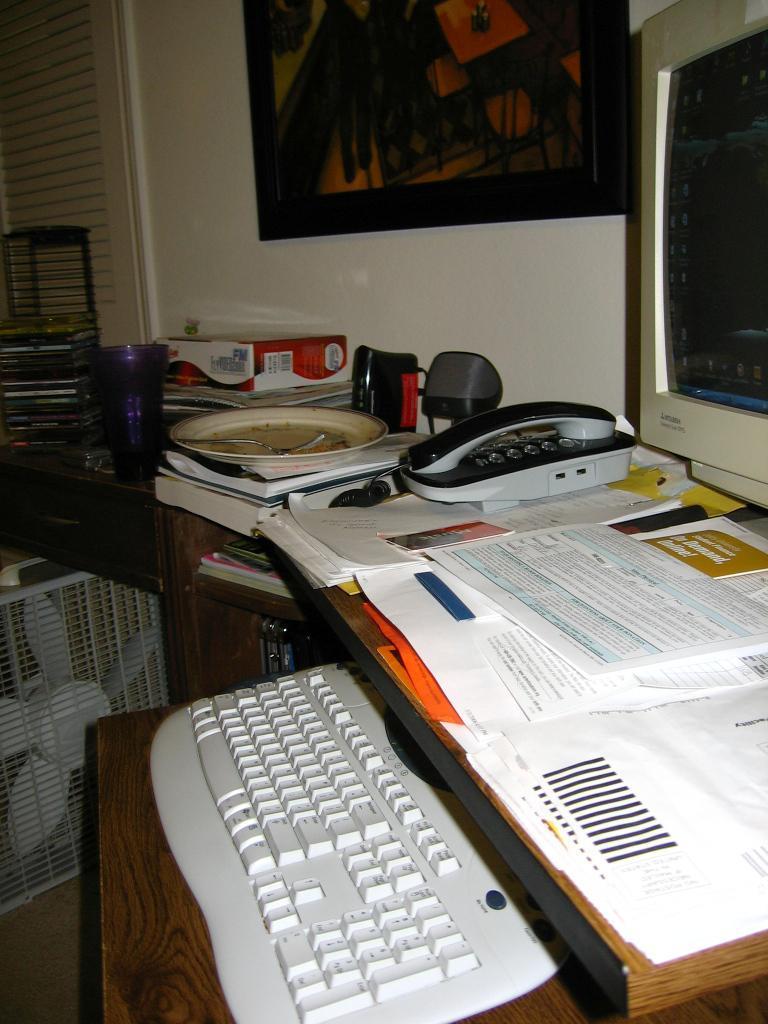How would you summarize this image in a sentence or two? This is a wooden table where a computer, a keyboard, a telephone, books and these papers are kept on this. Here we can see a cooler. 